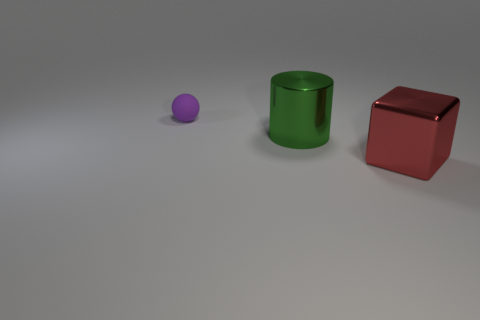Imagine these objects are part of a game, what kind of game could it be? If these objects were part of a game, it could be a sorting game where the goal is to categorize objects based on their shape or color. Another possibility is a balancing game, where players must stack the objects without letting them fall over. Alternatively, they could be representative pieces in a board game, serving as tokens or markers for each player. 